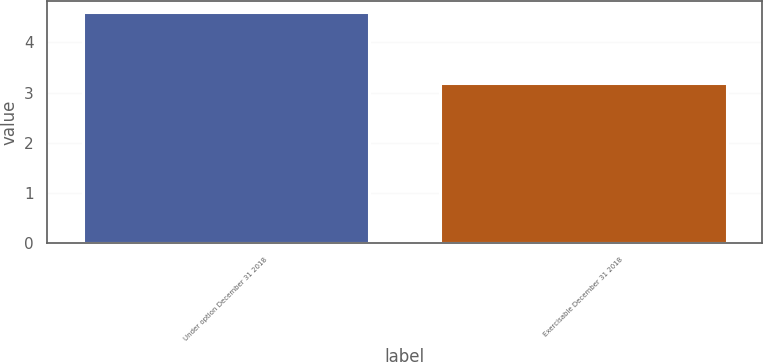<chart> <loc_0><loc_0><loc_500><loc_500><bar_chart><fcel>Under option December 31 2018<fcel>Exercisable December 31 2018<nl><fcel>4.6<fcel>3.2<nl></chart> 